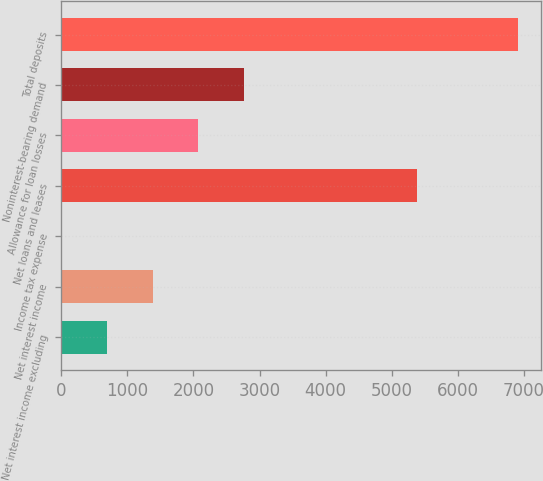Convert chart to OTSL. <chart><loc_0><loc_0><loc_500><loc_500><bar_chart><fcel>Net interest income excluding<fcel>Net interest income<fcel>Income tax expense<fcel>Net loans and leases<fcel>Allowance for loan losses<fcel>Noninterest-bearing demand<fcel>Total deposits<nl><fcel>693.47<fcel>1383.64<fcel>3.3<fcel>5389<fcel>2073.81<fcel>2763.98<fcel>6905<nl></chart> 